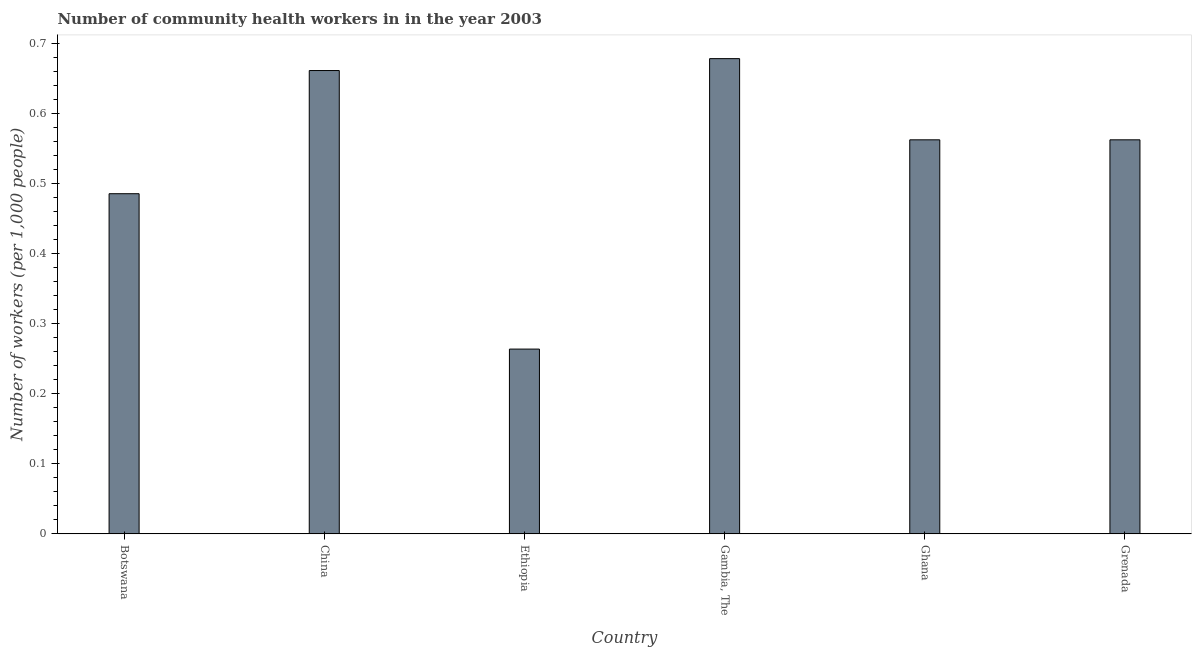Does the graph contain any zero values?
Give a very brief answer. No. Does the graph contain grids?
Your answer should be compact. No. What is the title of the graph?
Provide a short and direct response. Number of community health workers in in the year 2003. What is the label or title of the X-axis?
Make the answer very short. Country. What is the label or title of the Y-axis?
Offer a very short reply. Number of workers (per 1,0 people). What is the number of community health workers in Ghana?
Your response must be concise. 0.56. Across all countries, what is the maximum number of community health workers?
Offer a terse response. 0.68. Across all countries, what is the minimum number of community health workers?
Offer a very short reply. 0.26. In which country was the number of community health workers maximum?
Offer a very short reply. Gambia, The. In which country was the number of community health workers minimum?
Offer a very short reply. Ethiopia. What is the sum of the number of community health workers?
Provide a succinct answer. 3.22. What is the difference between the number of community health workers in Ethiopia and Ghana?
Offer a very short reply. -0.3. What is the average number of community health workers per country?
Your response must be concise. 0.54. What is the median number of community health workers?
Your response must be concise. 0.56. In how many countries, is the number of community health workers greater than 0.52 ?
Provide a succinct answer. 4. What is the ratio of the number of community health workers in China to that in Grenada?
Make the answer very short. 1.18. Is the number of community health workers in Ghana less than that in Grenada?
Provide a succinct answer. No. Is the difference between the number of community health workers in Botswana and Grenada greater than the difference between any two countries?
Keep it short and to the point. No. What is the difference between the highest and the second highest number of community health workers?
Provide a succinct answer. 0.02. What is the difference between the highest and the lowest number of community health workers?
Provide a succinct answer. 0.42. What is the Number of workers (per 1,000 people) of Botswana?
Your answer should be compact. 0.49. What is the Number of workers (per 1,000 people) in China?
Provide a short and direct response. 0.66. What is the Number of workers (per 1,000 people) in Ethiopia?
Provide a short and direct response. 0.26. What is the Number of workers (per 1,000 people) of Gambia, The?
Your response must be concise. 0.68. What is the Number of workers (per 1,000 people) in Ghana?
Your response must be concise. 0.56. What is the Number of workers (per 1,000 people) of Grenada?
Your answer should be very brief. 0.56. What is the difference between the Number of workers (per 1,000 people) in Botswana and China?
Keep it short and to the point. -0.18. What is the difference between the Number of workers (per 1,000 people) in Botswana and Ethiopia?
Make the answer very short. 0.22. What is the difference between the Number of workers (per 1,000 people) in Botswana and Gambia, The?
Your response must be concise. -0.19. What is the difference between the Number of workers (per 1,000 people) in Botswana and Ghana?
Provide a short and direct response. -0.08. What is the difference between the Number of workers (per 1,000 people) in Botswana and Grenada?
Your response must be concise. -0.08. What is the difference between the Number of workers (per 1,000 people) in China and Ethiopia?
Offer a very short reply. 0.4. What is the difference between the Number of workers (per 1,000 people) in China and Gambia, The?
Give a very brief answer. -0.02. What is the difference between the Number of workers (per 1,000 people) in China and Ghana?
Ensure brevity in your answer.  0.1. What is the difference between the Number of workers (per 1,000 people) in China and Grenada?
Your response must be concise. 0.1. What is the difference between the Number of workers (per 1,000 people) in Ethiopia and Gambia, The?
Provide a succinct answer. -0.41. What is the difference between the Number of workers (per 1,000 people) in Ethiopia and Ghana?
Your answer should be compact. -0.3. What is the difference between the Number of workers (per 1,000 people) in Ethiopia and Grenada?
Make the answer very short. -0.3. What is the difference between the Number of workers (per 1,000 people) in Gambia, The and Ghana?
Keep it short and to the point. 0.12. What is the difference between the Number of workers (per 1,000 people) in Gambia, The and Grenada?
Make the answer very short. 0.12. What is the ratio of the Number of workers (per 1,000 people) in Botswana to that in China?
Ensure brevity in your answer.  0.73. What is the ratio of the Number of workers (per 1,000 people) in Botswana to that in Ethiopia?
Provide a short and direct response. 1.84. What is the ratio of the Number of workers (per 1,000 people) in Botswana to that in Gambia, The?
Your response must be concise. 0.72. What is the ratio of the Number of workers (per 1,000 people) in Botswana to that in Ghana?
Make the answer very short. 0.86. What is the ratio of the Number of workers (per 1,000 people) in Botswana to that in Grenada?
Keep it short and to the point. 0.86. What is the ratio of the Number of workers (per 1,000 people) in China to that in Ethiopia?
Offer a terse response. 2.51. What is the ratio of the Number of workers (per 1,000 people) in China to that in Gambia, The?
Provide a succinct answer. 0.97. What is the ratio of the Number of workers (per 1,000 people) in China to that in Ghana?
Ensure brevity in your answer.  1.18. What is the ratio of the Number of workers (per 1,000 people) in China to that in Grenada?
Your answer should be compact. 1.18. What is the ratio of the Number of workers (per 1,000 people) in Ethiopia to that in Gambia, The?
Provide a succinct answer. 0.39. What is the ratio of the Number of workers (per 1,000 people) in Ethiopia to that in Ghana?
Offer a terse response. 0.47. What is the ratio of the Number of workers (per 1,000 people) in Ethiopia to that in Grenada?
Your answer should be very brief. 0.47. What is the ratio of the Number of workers (per 1,000 people) in Gambia, The to that in Ghana?
Keep it short and to the point. 1.21. What is the ratio of the Number of workers (per 1,000 people) in Gambia, The to that in Grenada?
Offer a very short reply. 1.21. What is the ratio of the Number of workers (per 1,000 people) in Ghana to that in Grenada?
Provide a succinct answer. 1. 